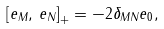<formula> <loc_0><loc_0><loc_500><loc_500>\left [ { e _ { M } , \, e _ { N } } \right ] _ { + } = - 2 \delta _ { M N } e _ { 0 } ,</formula> 